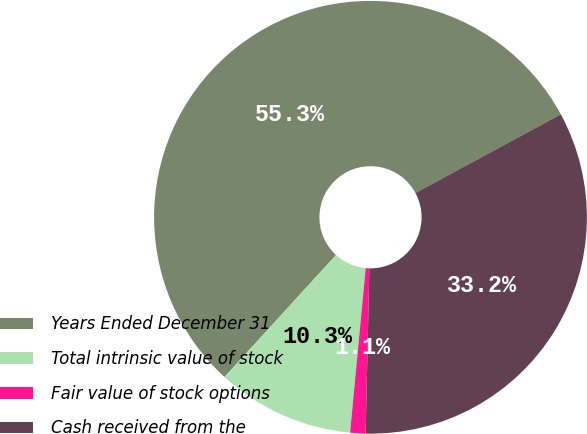<chart> <loc_0><loc_0><loc_500><loc_500><pie_chart><fcel>Years Ended December 31<fcel>Total intrinsic value of stock<fcel>Fair value of stock options<fcel>Cash received from the<nl><fcel>55.32%<fcel>10.28%<fcel>1.15%<fcel>33.25%<nl></chart> 